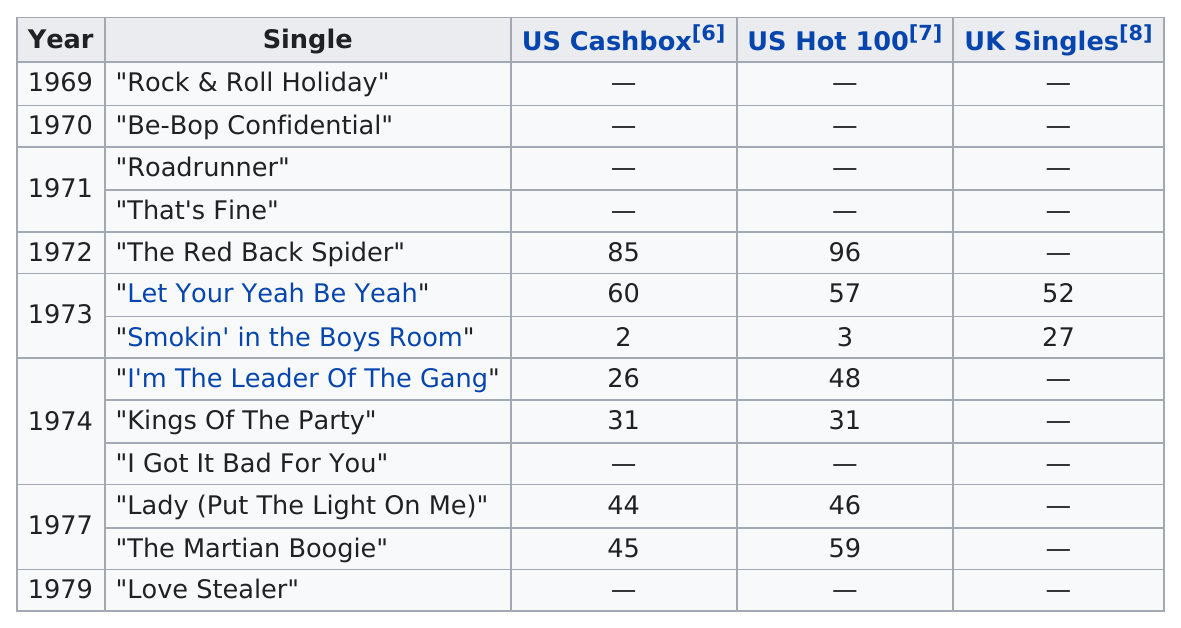Point out several critical features in this image. In 1974, the total number of singles was 3. Smokin' in the Boys Room" is a song that spent the least amount of time on the US Hot 100 chart. As of my knowledge cutoff, there have been a total of 13 singles released. The next single listed after "The Red Back Spider" is "Let Your Yeah Be Yeah. Five songs charted on both the US Cashbox and US Hot 100 charts, but not on the UK Singles chart. 